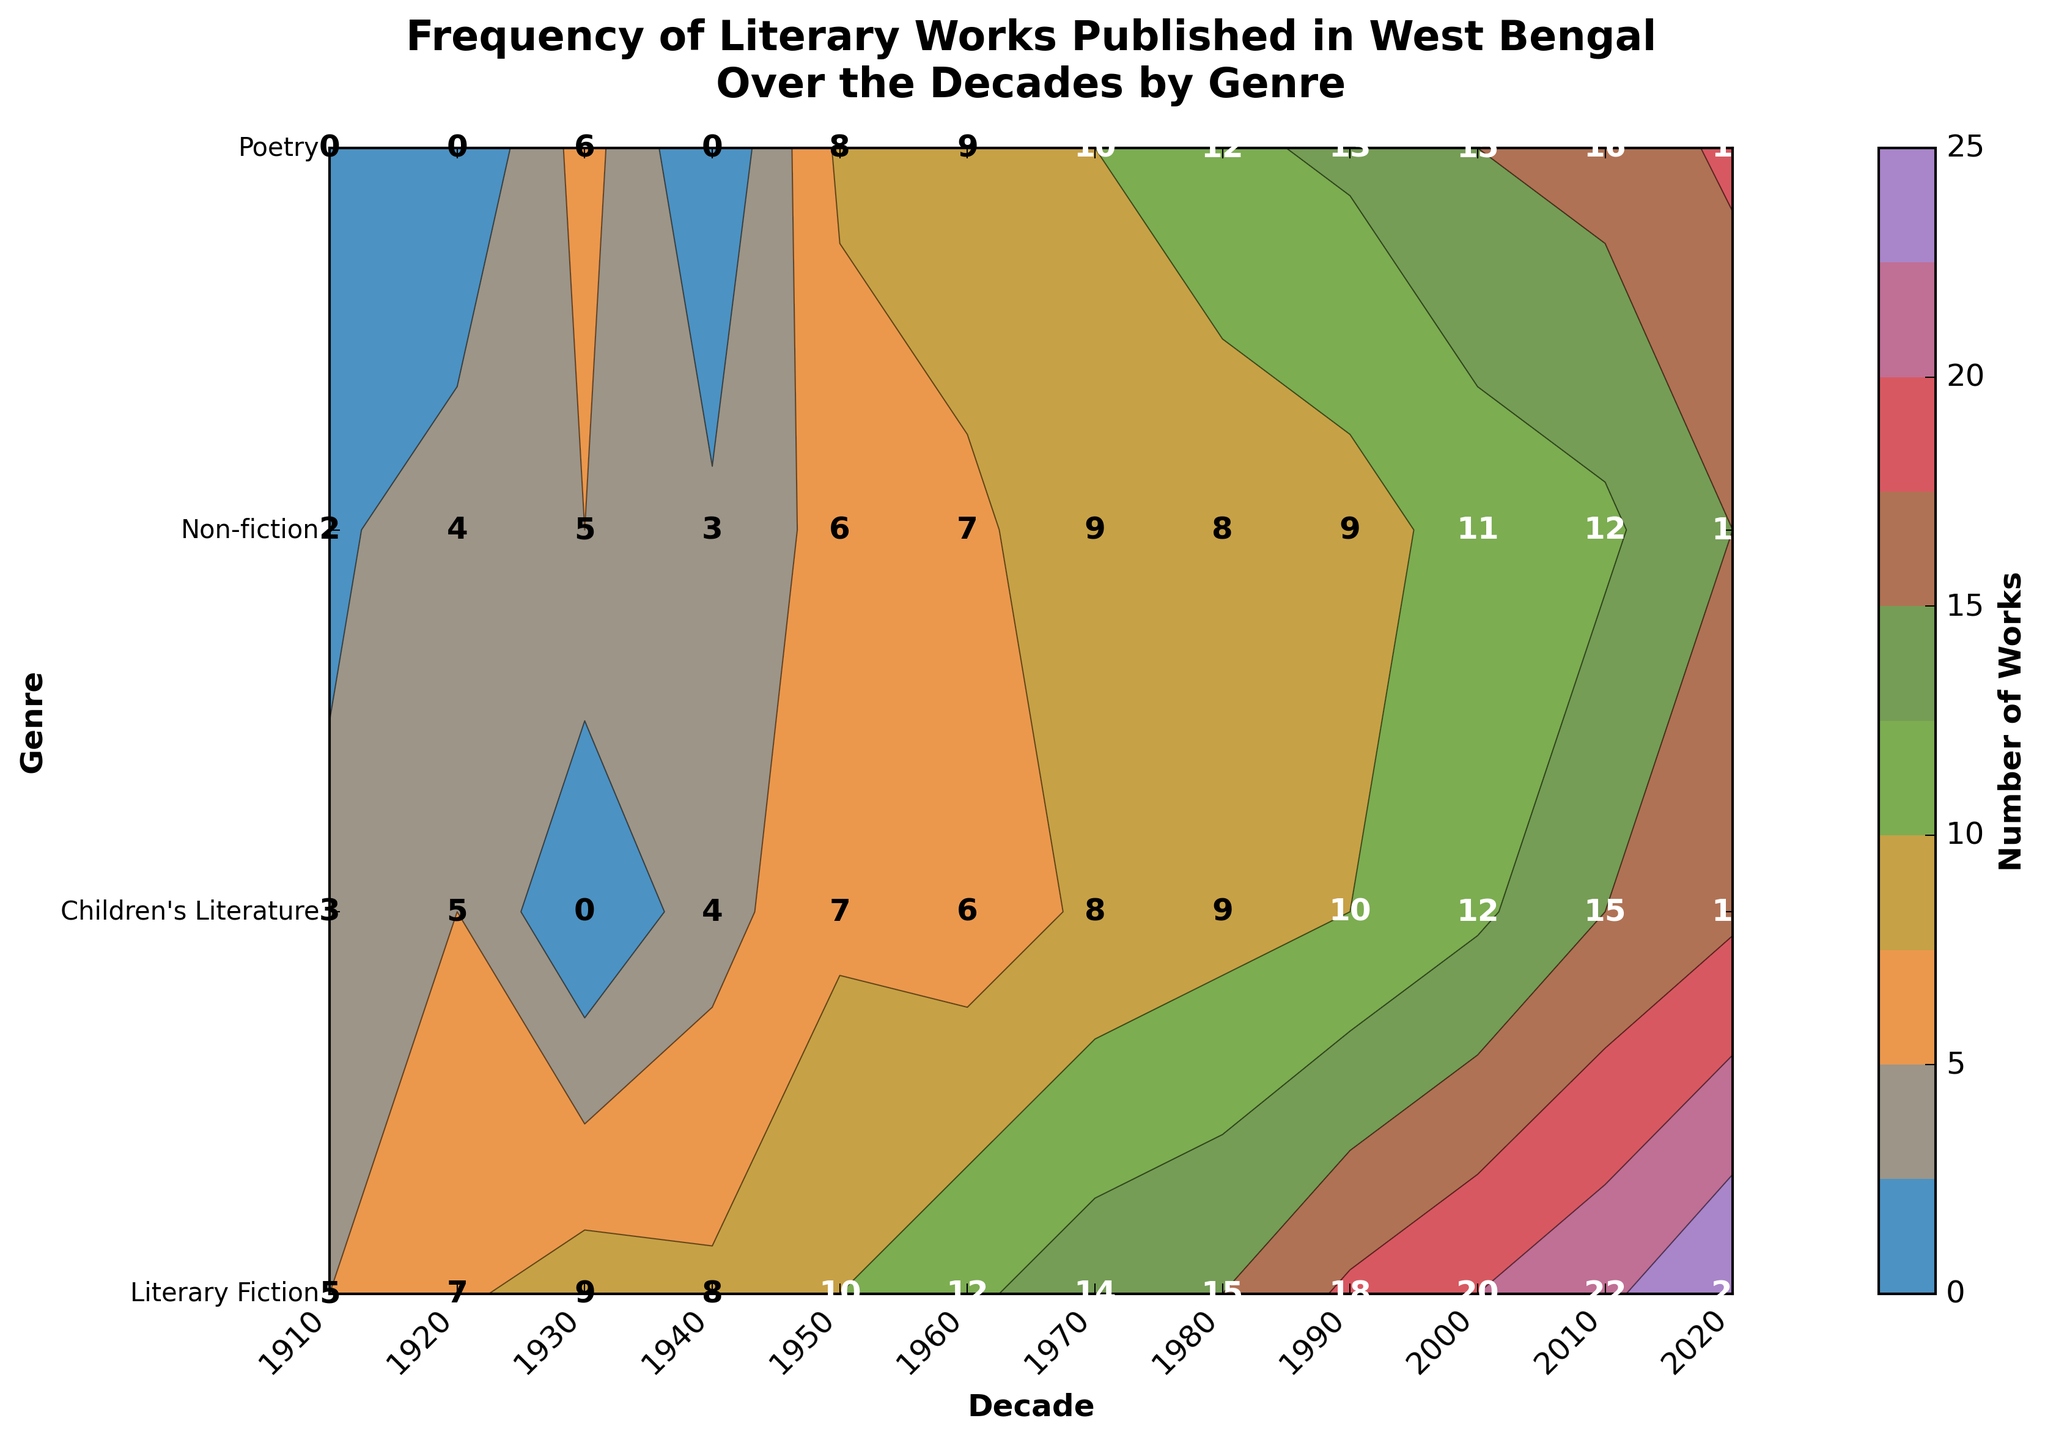What is the title of the contour plot? The title of the contour plot is usually displayed at the top of the figure in a larger font size. It helps to provide context for what the plot represents. In this plot, it clearly states "Frequency of Literary Works Published in West Bengal\nOver the Decades by Genre".
Answer: Frequency of Literary Works Published in West Bengal\nOver the Decades by Genre Which decade shows the highest number of Literary Fiction works published? Examining the x-axis for the decade labels and the corresponding contour levels for the genre "Literary Fiction," the highest count is observed in the year 2020 with the number 25 displayed at that point.
Answer: 2020 How many Children's Literature works were published in the 1950s? Looking at the y-axis to locate "Children's Literature" and then finding the corresponding z-value along the 1950s on the x-axis, the number displayed at this coordinate is 7.
Answer: 7 Which genre had the most consistent number of works published across decades? Consistency can be gauged by looking at the contour pattern along each row. For instance, "Non-fiction" seems to have a relatively stable count per decade with minor fluctuations, compared to other genres.
Answer: Non-fiction What is the total number of works published in the 1990s across all genres? To find the answer, sum the numbers displayed for each genre along the 1990s on the x-axis: Literary Fiction (18) + Poetry (13) + Children's Literature (10) + Non-fiction (9) = 50.
Answer: 50 Which genre had the least number of works published in the 1910s? Referring to the contour labels for each genre in the 1910s, "Non-fiction" shows the smallest count with a total of 2 works published.
Answer: Non-fiction Compare the number of Poetry works published in the 1930s and the 2000s. Which decade had more and by how much? Look at the values for Poetry in the 1930s and the 2000s. Poetry had 6 works published in the 1930s and 15 in the 2000s. The difference is 15 - 6 = 9 more works published in the 2000s.
Answer: 9 more in the 2000s Identify the decades where the number of Non-fiction works published was greater than 10. Examining the contour values for "Non-fiction" across all decades, the decade where the number exceeds 10 is the 2000s and 2010s with counts of 11 and 12 respectively.
Answer: 2000s, 2010s What trend do you observe in the number of Children's Literature works published from the 1910s to the 2020s? Observing the change in numbers along the row for "Children's Literature," there is a general increasing trend: 3, 5, 7, 9, 10, 12, 15, 17. This indicates a growing interest and publication in Children's Literature over the decades.
Answer: Increasing trend 